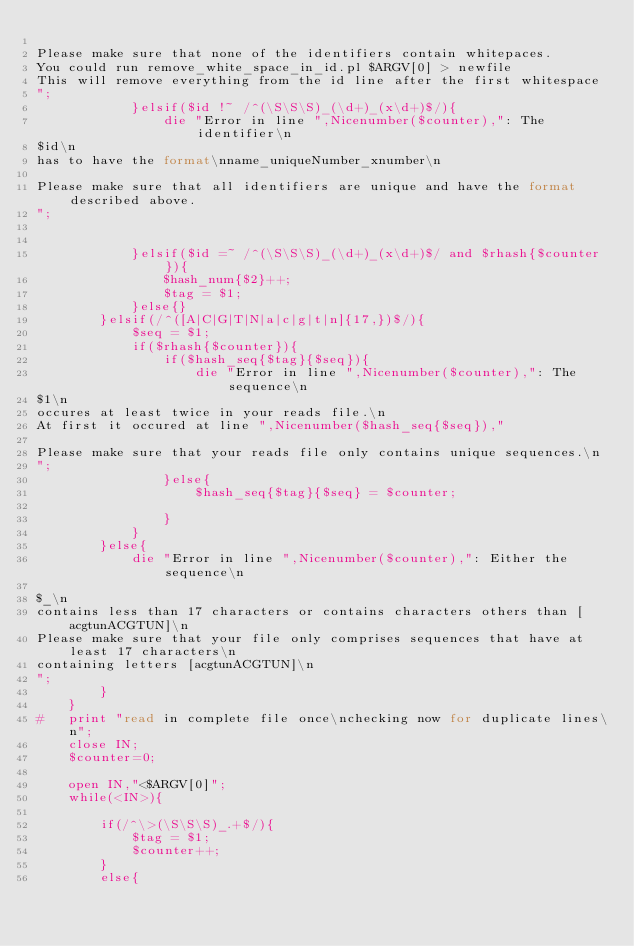Convert code to text. <code><loc_0><loc_0><loc_500><loc_500><_Perl_>
Please make sure that none of the identifiers contain whitepaces.
You could run remove_white_space_in_id.pl $ARGV[0] > newfile
This will remove everything from the id line after the first whitespace
";
            }elsif($id !~ /^(\S\S\S)_(\d+)_(x\d+)$/){
                die "Error in line ",Nicenumber($counter),": The identifier\n
$id\n
has to have the format\nname_uniqueNumber_xnumber\n

Please make sure that all identifiers are unique and have the format described above.
";


            }elsif($id =~ /^(\S\S\S)_(\d+)_(x\d+)$/ and $rhash{$counter}){
                $hash_num{$2}++;
                $tag = $1;
            }else{}
        }elsif(/^([A|C|G|T|N|a|c|g|t|n]{17,})$/){
            $seq = $1;
            if($rhash{$counter}){
                if($hash_seq{$tag}{$seq}){
                    die "Error in line ",Nicenumber($counter),": The sequence\n
$1\n
occures at least twice in your reads file.\n
At first it occured at line ",Nicenumber($hash_seq{$seq}),"

Please make sure that your reads file only contains unique sequences.\n
";
                }else{
                    $hash_seq{$tag}{$seq} = $counter;
                    
                }
            }
        }else{
            die "Error in line ",Nicenumber($counter),": Either the sequence\n

$_\n
contains less than 17 characters or contains characters others than [acgtunACGTUN]\n
Please make sure that your file only comprises sequences that have at least 17 characters\n
containing letters [acgtunACGTUN]\n
";
        }
    }
#   print "read in complete file once\nchecking now for duplicate lines\n";
    close IN;
    $counter=0;

    open IN,"<$ARGV[0]";
    while(<IN>){
        
        if(/^\>(\S\S\S)_.+$/){
            $tag = $1;
            $counter++;
        }
        else{</code> 